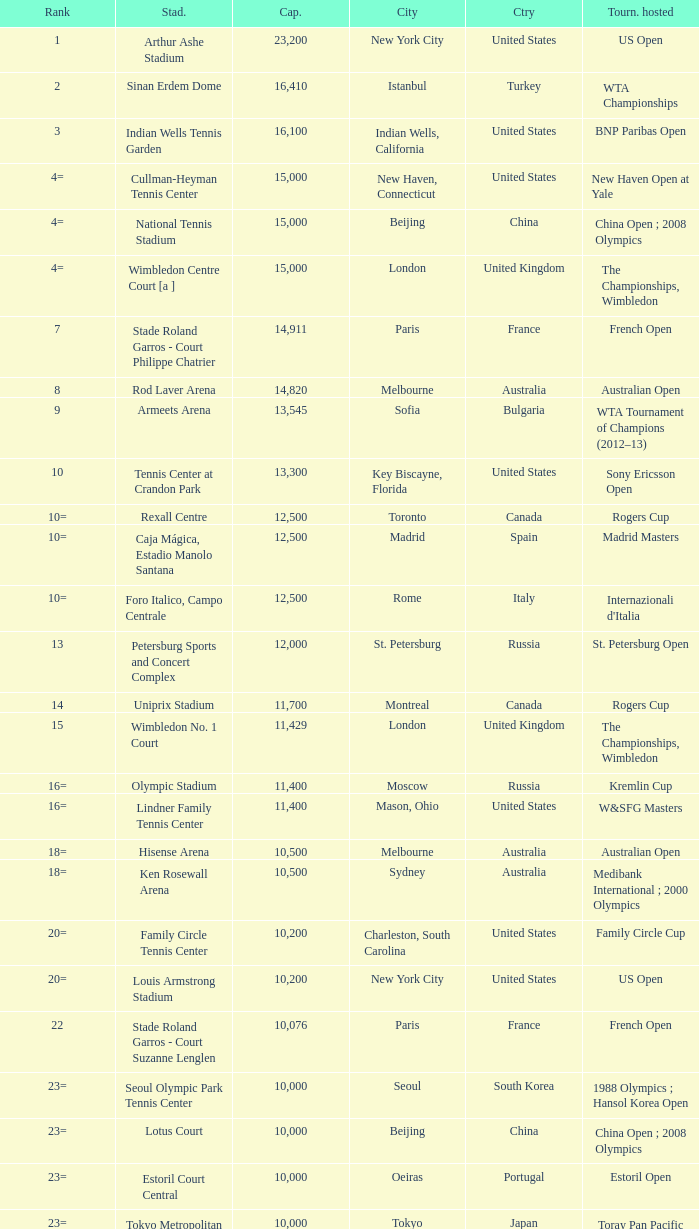What country has grandstand stadium as the stadium? United States. 